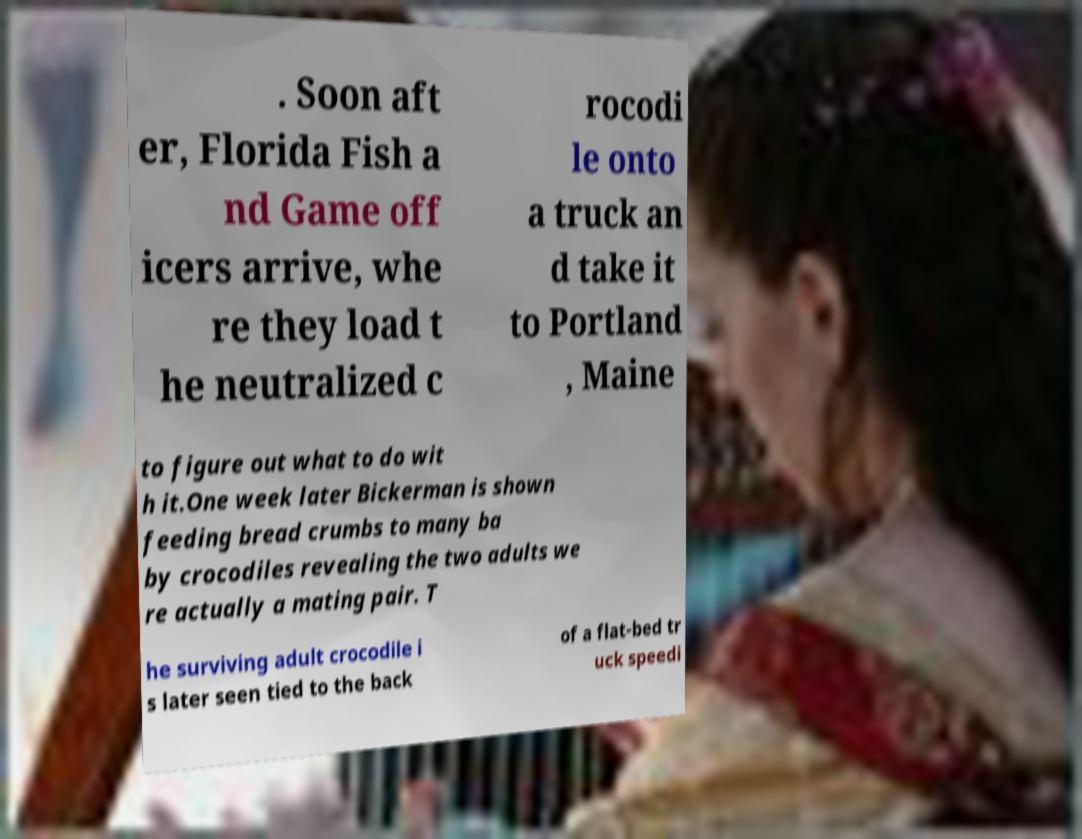Can you read and provide the text displayed in the image?This photo seems to have some interesting text. Can you extract and type it out for me? . Soon aft er, Florida Fish a nd Game off icers arrive, whe re they load t he neutralized c rocodi le onto a truck an d take it to Portland , Maine to figure out what to do wit h it.One week later Bickerman is shown feeding bread crumbs to many ba by crocodiles revealing the two adults we re actually a mating pair. T he surviving adult crocodile i s later seen tied to the back of a flat-bed tr uck speedi 